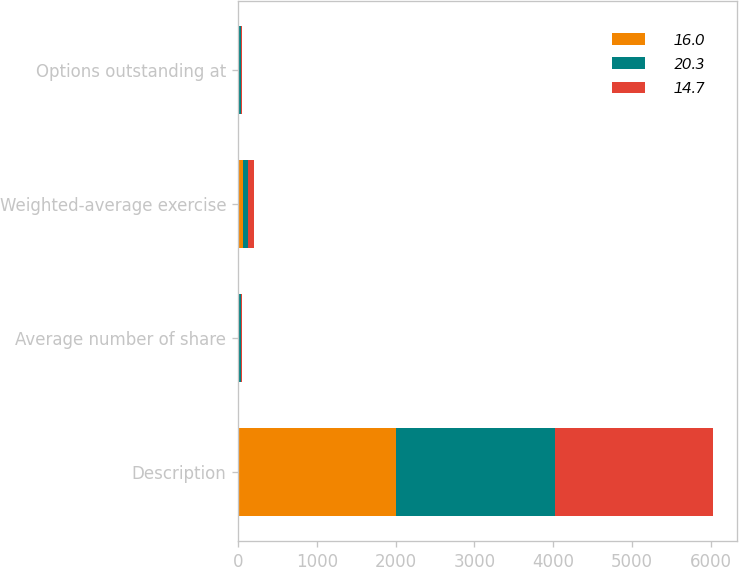Convert chart to OTSL. <chart><loc_0><loc_0><loc_500><loc_500><stacked_bar_chart><ecel><fcel>Description<fcel>Average number of share<fcel>Weighted-average exercise<fcel>Options outstanding at<nl><fcel>16<fcel>2010<fcel>13.9<fcel>66<fcel>14.7<nl><fcel>20.3<fcel>2009<fcel>21.8<fcel>64.12<fcel>20.3<nl><fcel>14.7<fcel>2008<fcel>15.6<fcel>66.31<fcel>16<nl></chart> 